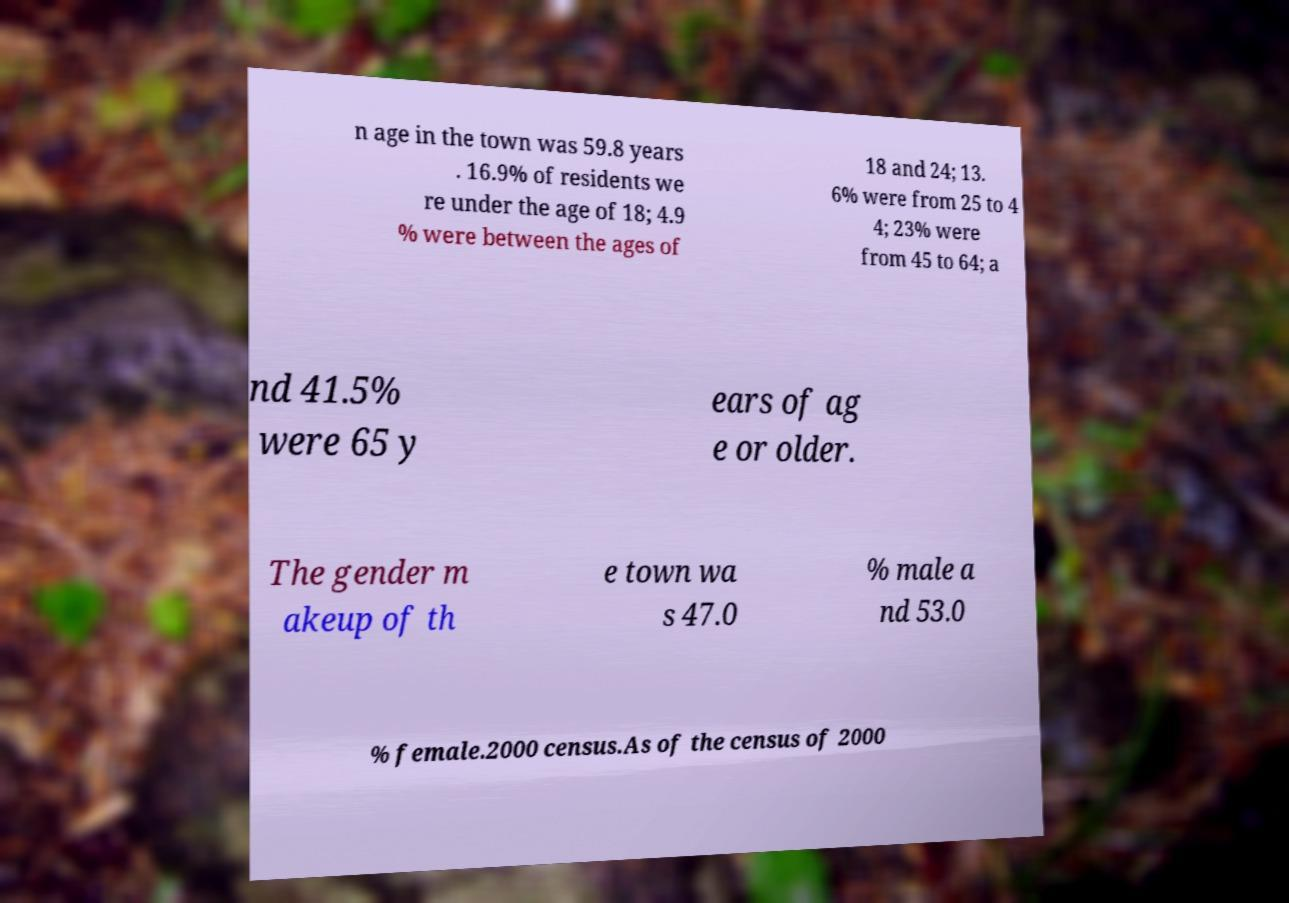For documentation purposes, I need the text within this image transcribed. Could you provide that? n age in the town was 59.8 years . 16.9% of residents we re under the age of 18; 4.9 % were between the ages of 18 and 24; 13. 6% were from 25 to 4 4; 23% were from 45 to 64; a nd 41.5% were 65 y ears of ag e or older. The gender m akeup of th e town wa s 47.0 % male a nd 53.0 % female.2000 census.As of the census of 2000 